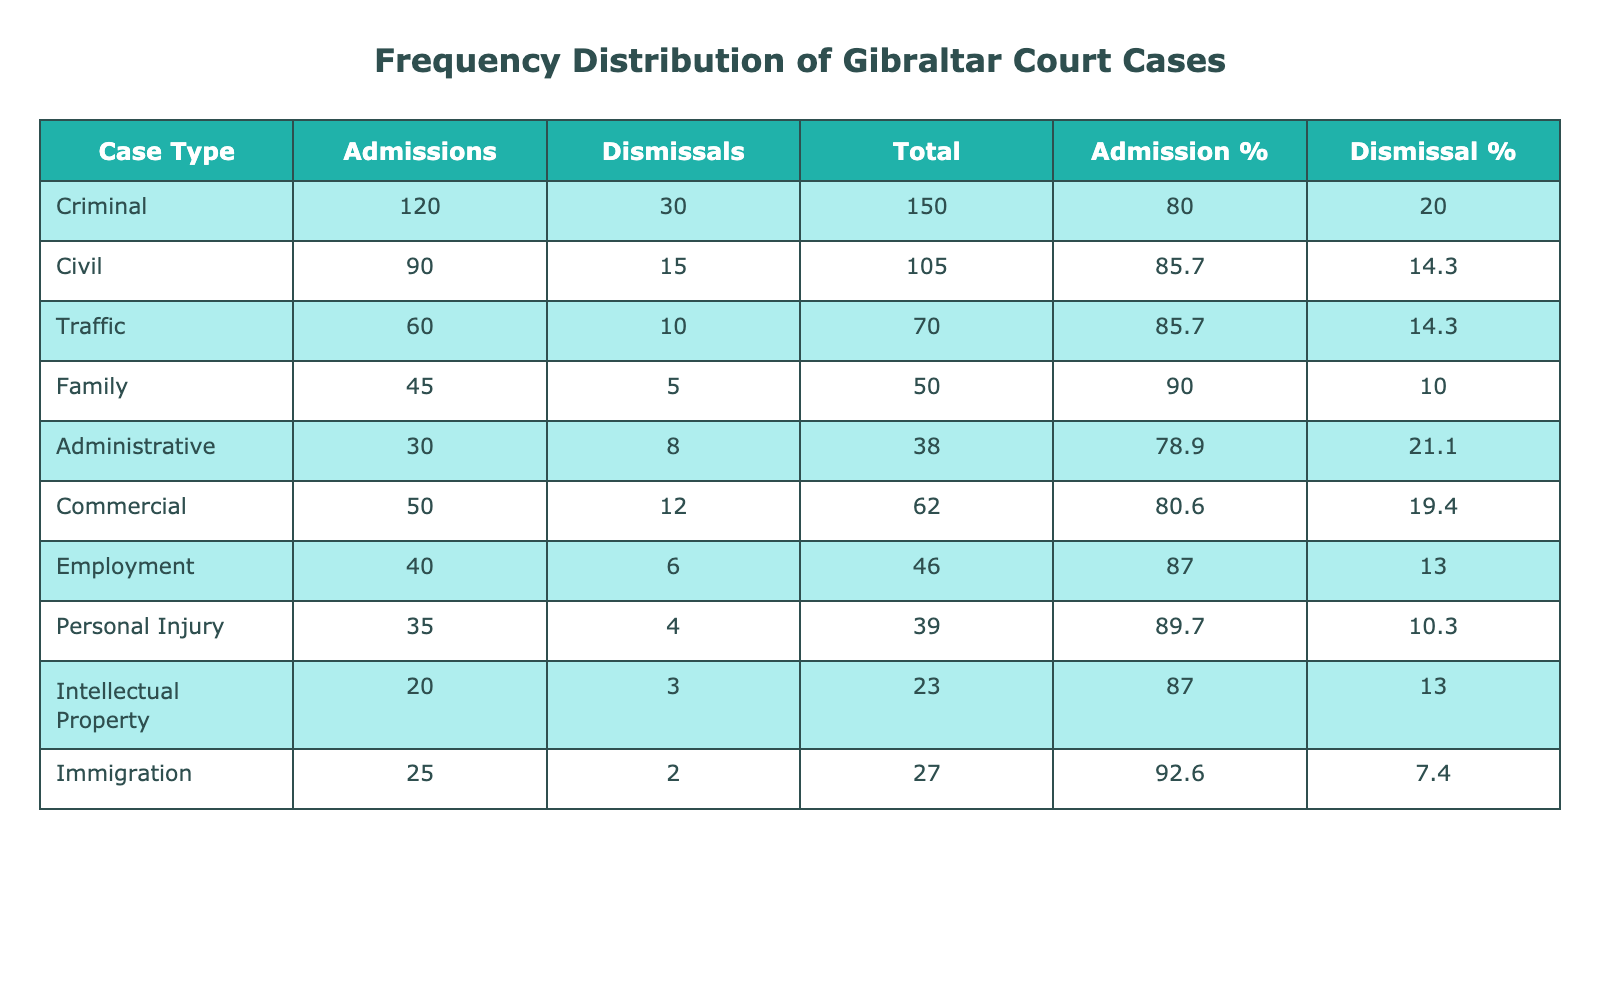What is the total number of admissions for Criminal cases? The table indicates that there are 120 admissions under the Criminal case type. Thus, the answer is directly retrievable from the "Admissions" column for Criminal cases.
Answer: 120 What percentage of Family case admissions were successful? To determine the percentage of admissions that were successful, divide the number of admissions (45) by the total number of Family cases (admissions + dismissals = 45 + 5 = 50). Then multiply by 100 to convert to a percentage: (45 / 50) × 100 = 90%.
Answer: 90% Which case type has the highest number of dismissals? By examining the "Dismissals" column, it is clear that Criminal cases have the highest number of dismissals at 30, which is greater than any other case type listed.
Answer: Criminal Is the number of Personal Injury admissions higher than the number of Immigration admissions? Looking at the table, Personal Injury has 35 admissions, while Immigration has 25 admissions. Since 35 is greater than 25, the statement is true.
Answer: Yes What is the total number of cases (admissions + dismissals) across all case types? To find the total number of cases, sum the total admissions and dismissals across all case types. This calculation is: (120 + 30) + (90 + 15) + (60 + 10) + (45 + 5) + (30 + 8) + (50 + 12) + (40 + 6) + (35 + 4) + (20 + 3) + (25 + 2) = 443.
Answer: 443 What is the average number of admissions for all case types? First, sum the admissions for all case types: 120 + 90 + 60 + 45 + 30 + 50 + 40 + 35 + 20 + 25 = 510. Then divide by the number of case types, which is 10. This gives: 510 / 10 = 51.
Answer: 51 Are dismissals for Commercial cases higher than for Employment cases? The table lists 12 dismissals for Commercial cases and 6 for Employment cases. Since 12 is greater than 6, the answer is true.
Answer: Yes What is the ratio of admissions to dismissals for the Traffic case type? For Traffic cases, there are 60 admissions and 10 dismissals. The ratio of admissions to dismissals is calculated by dividing the number of admissions by the number of dismissals: 60 / 10 = 6. Thus, the ratio is 6:1.
Answer: 6:1 